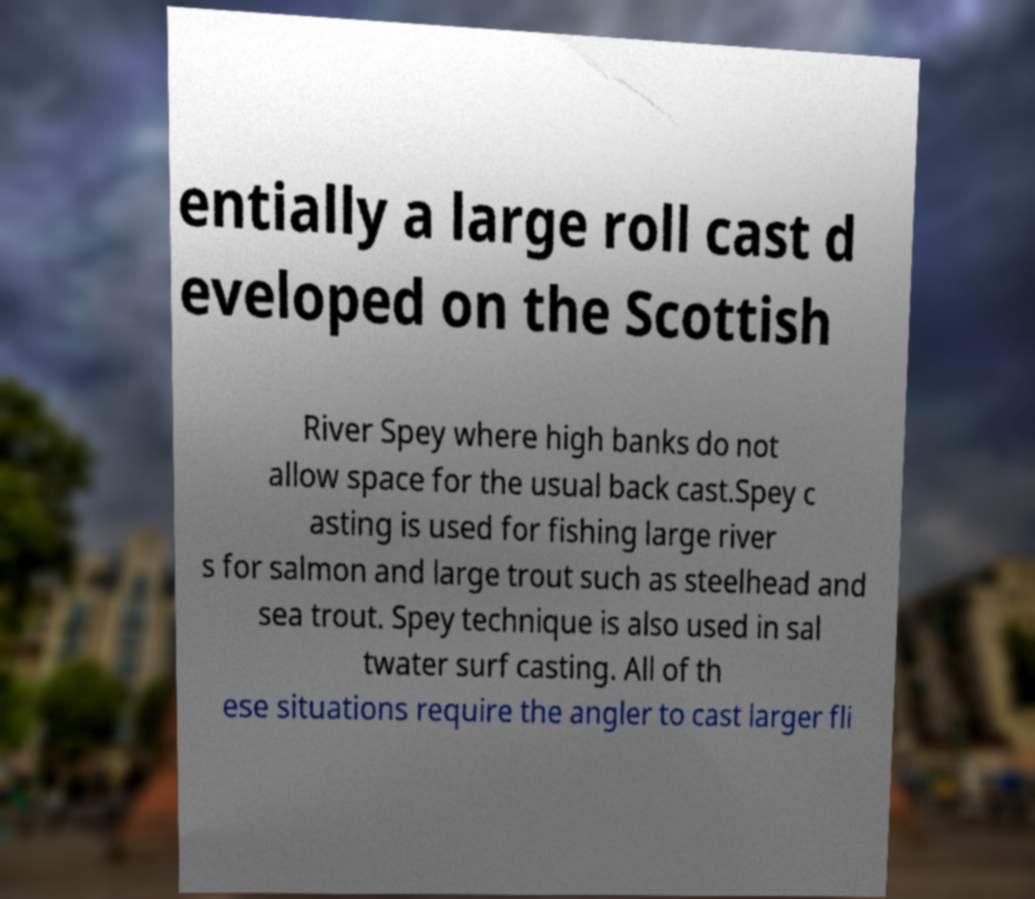Can you accurately transcribe the text from the provided image for me? entially a large roll cast d eveloped on the Scottish River Spey where high banks do not allow space for the usual back cast.Spey c asting is used for fishing large river s for salmon and large trout such as steelhead and sea trout. Spey technique is also used in sal twater surf casting. All of th ese situations require the angler to cast larger fli 